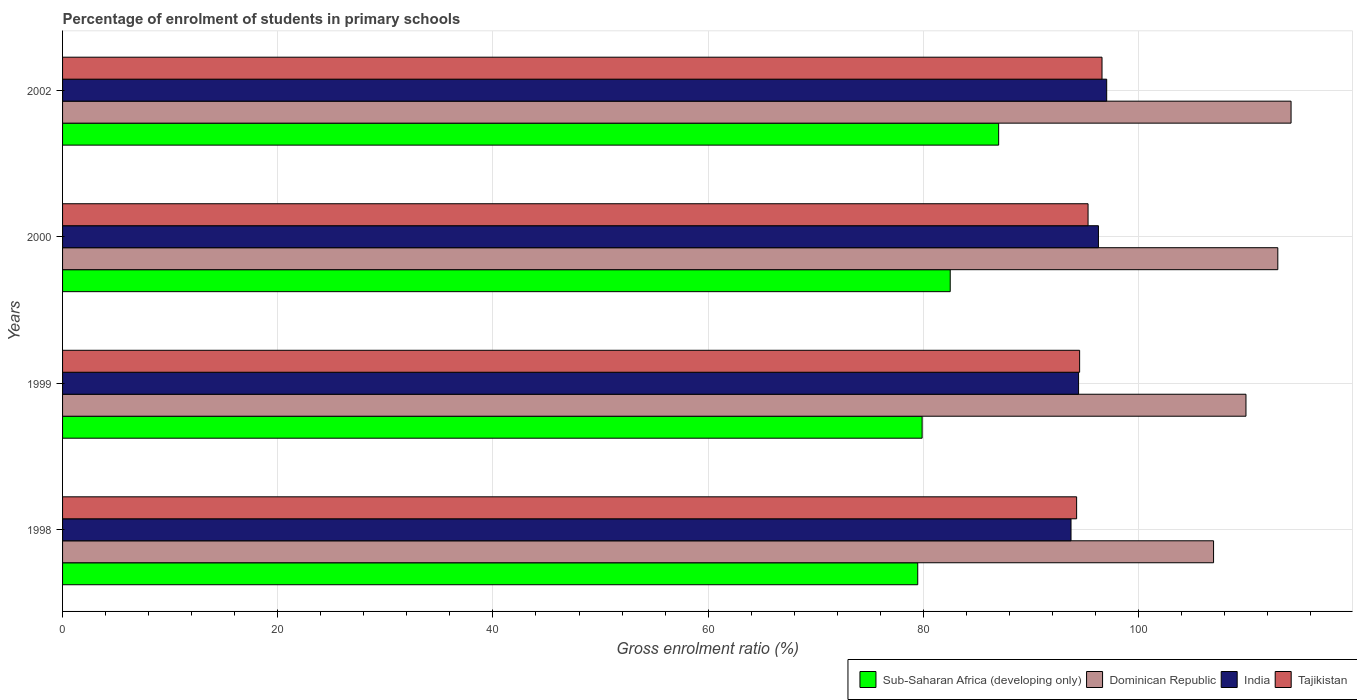How many groups of bars are there?
Give a very brief answer. 4. How many bars are there on the 2nd tick from the bottom?
Your answer should be very brief. 4. What is the label of the 4th group of bars from the top?
Your answer should be very brief. 1998. What is the percentage of students enrolled in primary schools in Dominican Republic in 1999?
Provide a short and direct response. 109.99. Across all years, what is the maximum percentage of students enrolled in primary schools in Sub-Saharan Africa (developing only)?
Provide a succinct answer. 87. Across all years, what is the minimum percentage of students enrolled in primary schools in Tajikistan?
Make the answer very short. 94.25. In which year was the percentage of students enrolled in primary schools in Dominican Republic maximum?
Make the answer very short. 2002. What is the total percentage of students enrolled in primary schools in Dominican Republic in the graph?
Provide a short and direct response. 444.09. What is the difference between the percentage of students enrolled in primary schools in Tajikistan in 1998 and that in 1999?
Your response must be concise. -0.28. What is the difference between the percentage of students enrolled in primary schools in Dominican Republic in 2000 and the percentage of students enrolled in primary schools in India in 2002?
Provide a succinct answer. 15.9. What is the average percentage of students enrolled in primary schools in Dominican Republic per year?
Ensure brevity in your answer.  111.02. In the year 2002, what is the difference between the percentage of students enrolled in primary schools in Dominican Republic and percentage of students enrolled in primary schools in Tajikistan?
Give a very brief answer. 17.57. What is the ratio of the percentage of students enrolled in primary schools in Sub-Saharan Africa (developing only) in 1998 to that in 2000?
Offer a very short reply. 0.96. Is the percentage of students enrolled in primary schools in India in 1999 less than that in 2000?
Provide a short and direct response. Yes. Is the difference between the percentage of students enrolled in primary schools in Dominican Republic in 1998 and 2002 greater than the difference between the percentage of students enrolled in primary schools in Tajikistan in 1998 and 2002?
Your answer should be very brief. No. What is the difference between the highest and the second highest percentage of students enrolled in primary schools in Tajikistan?
Offer a terse response. 1.3. What is the difference between the highest and the lowest percentage of students enrolled in primary schools in Sub-Saharan Africa (developing only)?
Your answer should be very brief. 7.52. In how many years, is the percentage of students enrolled in primary schools in Tajikistan greater than the average percentage of students enrolled in primary schools in Tajikistan taken over all years?
Your response must be concise. 2. What does the 1st bar from the bottom in 1999 represents?
Your response must be concise. Sub-Saharan Africa (developing only). Are all the bars in the graph horizontal?
Provide a short and direct response. Yes. Are the values on the major ticks of X-axis written in scientific E-notation?
Give a very brief answer. No. Does the graph contain grids?
Give a very brief answer. Yes. How many legend labels are there?
Ensure brevity in your answer.  4. What is the title of the graph?
Provide a short and direct response. Percentage of enrolment of students in primary schools. What is the label or title of the X-axis?
Make the answer very short. Gross enrolment ratio (%). What is the label or title of the Y-axis?
Ensure brevity in your answer.  Years. What is the Gross enrolment ratio (%) of Sub-Saharan Africa (developing only) in 1998?
Offer a very short reply. 79.48. What is the Gross enrolment ratio (%) of Dominican Republic in 1998?
Offer a very short reply. 106.98. What is the Gross enrolment ratio (%) in India in 1998?
Ensure brevity in your answer.  93.73. What is the Gross enrolment ratio (%) in Tajikistan in 1998?
Provide a short and direct response. 94.25. What is the Gross enrolment ratio (%) of Sub-Saharan Africa (developing only) in 1999?
Ensure brevity in your answer.  79.89. What is the Gross enrolment ratio (%) of Dominican Republic in 1999?
Your answer should be compact. 109.99. What is the Gross enrolment ratio (%) in India in 1999?
Give a very brief answer. 94.43. What is the Gross enrolment ratio (%) in Tajikistan in 1999?
Make the answer very short. 94.53. What is the Gross enrolment ratio (%) of Sub-Saharan Africa (developing only) in 2000?
Provide a succinct answer. 82.5. What is the Gross enrolment ratio (%) of Dominican Republic in 2000?
Give a very brief answer. 112.95. What is the Gross enrolment ratio (%) of India in 2000?
Ensure brevity in your answer.  96.28. What is the Gross enrolment ratio (%) of Tajikistan in 2000?
Give a very brief answer. 95.31. What is the Gross enrolment ratio (%) in Sub-Saharan Africa (developing only) in 2002?
Make the answer very short. 87. What is the Gross enrolment ratio (%) in Dominican Republic in 2002?
Provide a short and direct response. 114.18. What is the Gross enrolment ratio (%) of India in 2002?
Keep it short and to the point. 97.04. What is the Gross enrolment ratio (%) in Tajikistan in 2002?
Your answer should be compact. 96.61. Across all years, what is the maximum Gross enrolment ratio (%) of Sub-Saharan Africa (developing only)?
Provide a short and direct response. 87. Across all years, what is the maximum Gross enrolment ratio (%) of Dominican Republic?
Provide a short and direct response. 114.18. Across all years, what is the maximum Gross enrolment ratio (%) of India?
Make the answer very short. 97.04. Across all years, what is the maximum Gross enrolment ratio (%) in Tajikistan?
Offer a terse response. 96.61. Across all years, what is the minimum Gross enrolment ratio (%) in Sub-Saharan Africa (developing only)?
Give a very brief answer. 79.48. Across all years, what is the minimum Gross enrolment ratio (%) in Dominican Republic?
Your response must be concise. 106.98. Across all years, what is the minimum Gross enrolment ratio (%) in India?
Provide a succinct answer. 93.73. Across all years, what is the minimum Gross enrolment ratio (%) of Tajikistan?
Ensure brevity in your answer.  94.25. What is the total Gross enrolment ratio (%) in Sub-Saharan Africa (developing only) in the graph?
Offer a very short reply. 328.87. What is the total Gross enrolment ratio (%) of Dominican Republic in the graph?
Offer a very short reply. 444.09. What is the total Gross enrolment ratio (%) in India in the graph?
Your answer should be very brief. 381.48. What is the total Gross enrolment ratio (%) of Tajikistan in the graph?
Offer a very short reply. 380.7. What is the difference between the Gross enrolment ratio (%) of Sub-Saharan Africa (developing only) in 1998 and that in 1999?
Offer a terse response. -0.41. What is the difference between the Gross enrolment ratio (%) in Dominican Republic in 1998 and that in 1999?
Keep it short and to the point. -3.01. What is the difference between the Gross enrolment ratio (%) in India in 1998 and that in 1999?
Ensure brevity in your answer.  -0.7. What is the difference between the Gross enrolment ratio (%) of Tajikistan in 1998 and that in 1999?
Offer a very short reply. -0.28. What is the difference between the Gross enrolment ratio (%) in Sub-Saharan Africa (developing only) in 1998 and that in 2000?
Your answer should be very brief. -3.02. What is the difference between the Gross enrolment ratio (%) in Dominican Republic in 1998 and that in 2000?
Your answer should be compact. -5.97. What is the difference between the Gross enrolment ratio (%) of India in 1998 and that in 2000?
Provide a short and direct response. -2.55. What is the difference between the Gross enrolment ratio (%) in Tajikistan in 1998 and that in 2000?
Your response must be concise. -1.06. What is the difference between the Gross enrolment ratio (%) in Sub-Saharan Africa (developing only) in 1998 and that in 2002?
Provide a short and direct response. -7.52. What is the difference between the Gross enrolment ratio (%) of Dominican Republic in 1998 and that in 2002?
Offer a very short reply. -7.2. What is the difference between the Gross enrolment ratio (%) of India in 1998 and that in 2002?
Your answer should be compact. -3.32. What is the difference between the Gross enrolment ratio (%) in Tajikistan in 1998 and that in 2002?
Ensure brevity in your answer.  -2.36. What is the difference between the Gross enrolment ratio (%) of Sub-Saharan Africa (developing only) in 1999 and that in 2000?
Make the answer very short. -2.61. What is the difference between the Gross enrolment ratio (%) in Dominican Republic in 1999 and that in 2000?
Your answer should be compact. -2.96. What is the difference between the Gross enrolment ratio (%) in India in 1999 and that in 2000?
Your response must be concise. -1.85. What is the difference between the Gross enrolment ratio (%) in Tajikistan in 1999 and that in 2000?
Make the answer very short. -0.78. What is the difference between the Gross enrolment ratio (%) of Sub-Saharan Africa (developing only) in 1999 and that in 2002?
Your response must be concise. -7.11. What is the difference between the Gross enrolment ratio (%) in Dominican Republic in 1999 and that in 2002?
Ensure brevity in your answer.  -4.19. What is the difference between the Gross enrolment ratio (%) of India in 1999 and that in 2002?
Your response must be concise. -2.61. What is the difference between the Gross enrolment ratio (%) of Tajikistan in 1999 and that in 2002?
Your answer should be very brief. -2.08. What is the difference between the Gross enrolment ratio (%) in Sub-Saharan Africa (developing only) in 2000 and that in 2002?
Provide a short and direct response. -4.5. What is the difference between the Gross enrolment ratio (%) of Dominican Republic in 2000 and that in 2002?
Your answer should be very brief. -1.23. What is the difference between the Gross enrolment ratio (%) of India in 2000 and that in 2002?
Make the answer very short. -0.77. What is the difference between the Gross enrolment ratio (%) in Tajikistan in 2000 and that in 2002?
Offer a terse response. -1.3. What is the difference between the Gross enrolment ratio (%) in Sub-Saharan Africa (developing only) in 1998 and the Gross enrolment ratio (%) in Dominican Republic in 1999?
Your answer should be compact. -30.51. What is the difference between the Gross enrolment ratio (%) of Sub-Saharan Africa (developing only) in 1998 and the Gross enrolment ratio (%) of India in 1999?
Provide a succinct answer. -14.95. What is the difference between the Gross enrolment ratio (%) of Sub-Saharan Africa (developing only) in 1998 and the Gross enrolment ratio (%) of Tajikistan in 1999?
Your answer should be compact. -15.05. What is the difference between the Gross enrolment ratio (%) of Dominican Republic in 1998 and the Gross enrolment ratio (%) of India in 1999?
Give a very brief answer. 12.55. What is the difference between the Gross enrolment ratio (%) of Dominican Republic in 1998 and the Gross enrolment ratio (%) of Tajikistan in 1999?
Keep it short and to the point. 12.45. What is the difference between the Gross enrolment ratio (%) in India in 1998 and the Gross enrolment ratio (%) in Tajikistan in 1999?
Offer a terse response. -0.8. What is the difference between the Gross enrolment ratio (%) in Sub-Saharan Africa (developing only) in 1998 and the Gross enrolment ratio (%) in Dominican Republic in 2000?
Provide a succinct answer. -33.47. What is the difference between the Gross enrolment ratio (%) of Sub-Saharan Africa (developing only) in 1998 and the Gross enrolment ratio (%) of India in 2000?
Give a very brief answer. -16.79. What is the difference between the Gross enrolment ratio (%) of Sub-Saharan Africa (developing only) in 1998 and the Gross enrolment ratio (%) of Tajikistan in 2000?
Offer a very short reply. -15.83. What is the difference between the Gross enrolment ratio (%) of Dominican Republic in 1998 and the Gross enrolment ratio (%) of India in 2000?
Offer a terse response. 10.7. What is the difference between the Gross enrolment ratio (%) in Dominican Republic in 1998 and the Gross enrolment ratio (%) in Tajikistan in 2000?
Your answer should be compact. 11.67. What is the difference between the Gross enrolment ratio (%) in India in 1998 and the Gross enrolment ratio (%) in Tajikistan in 2000?
Your answer should be very brief. -1.58. What is the difference between the Gross enrolment ratio (%) of Sub-Saharan Africa (developing only) in 1998 and the Gross enrolment ratio (%) of Dominican Republic in 2002?
Provide a short and direct response. -34.7. What is the difference between the Gross enrolment ratio (%) in Sub-Saharan Africa (developing only) in 1998 and the Gross enrolment ratio (%) in India in 2002?
Provide a short and direct response. -17.56. What is the difference between the Gross enrolment ratio (%) in Sub-Saharan Africa (developing only) in 1998 and the Gross enrolment ratio (%) in Tajikistan in 2002?
Give a very brief answer. -17.13. What is the difference between the Gross enrolment ratio (%) of Dominican Republic in 1998 and the Gross enrolment ratio (%) of India in 2002?
Offer a very short reply. 9.93. What is the difference between the Gross enrolment ratio (%) of Dominican Republic in 1998 and the Gross enrolment ratio (%) of Tajikistan in 2002?
Provide a short and direct response. 10.37. What is the difference between the Gross enrolment ratio (%) in India in 1998 and the Gross enrolment ratio (%) in Tajikistan in 2002?
Your answer should be very brief. -2.88. What is the difference between the Gross enrolment ratio (%) in Sub-Saharan Africa (developing only) in 1999 and the Gross enrolment ratio (%) in Dominican Republic in 2000?
Make the answer very short. -33.06. What is the difference between the Gross enrolment ratio (%) of Sub-Saharan Africa (developing only) in 1999 and the Gross enrolment ratio (%) of India in 2000?
Provide a short and direct response. -16.39. What is the difference between the Gross enrolment ratio (%) in Sub-Saharan Africa (developing only) in 1999 and the Gross enrolment ratio (%) in Tajikistan in 2000?
Provide a succinct answer. -15.42. What is the difference between the Gross enrolment ratio (%) in Dominican Republic in 1999 and the Gross enrolment ratio (%) in India in 2000?
Your answer should be compact. 13.71. What is the difference between the Gross enrolment ratio (%) of Dominican Republic in 1999 and the Gross enrolment ratio (%) of Tajikistan in 2000?
Provide a succinct answer. 14.68. What is the difference between the Gross enrolment ratio (%) in India in 1999 and the Gross enrolment ratio (%) in Tajikistan in 2000?
Make the answer very short. -0.88. What is the difference between the Gross enrolment ratio (%) of Sub-Saharan Africa (developing only) in 1999 and the Gross enrolment ratio (%) of Dominican Republic in 2002?
Give a very brief answer. -34.29. What is the difference between the Gross enrolment ratio (%) of Sub-Saharan Africa (developing only) in 1999 and the Gross enrolment ratio (%) of India in 2002?
Your answer should be very brief. -17.15. What is the difference between the Gross enrolment ratio (%) in Sub-Saharan Africa (developing only) in 1999 and the Gross enrolment ratio (%) in Tajikistan in 2002?
Provide a succinct answer. -16.72. What is the difference between the Gross enrolment ratio (%) in Dominican Republic in 1999 and the Gross enrolment ratio (%) in India in 2002?
Make the answer very short. 12.95. What is the difference between the Gross enrolment ratio (%) of Dominican Republic in 1999 and the Gross enrolment ratio (%) of Tajikistan in 2002?
Give a very brief answer. 13.38. What is the difference between the Gross enrolment ratio (%) of India in 1999 and the Gross enrolment ratio (%) of Tajikistan in 2002?
Offer a terse response. -2.18. What is the difference between the Gross enrolment ratio (%) in Sub-Saharan Africa (developing only) in 2000 and the Gross enrolment ratio (%) in Dominican Republic in 2002?
Provide a succinct answer. -31.68. What is the difference between the Gross enrolment ratio (%) in Sub-Saharan Africa (developing only) in 2000 and the Gross enrolment ratio (%) in India in 2002?
Keep it short and to the point. -14.54. What is the difference between the Gross enrolment ratio (%) of Sub-Saharan Africa (developing only) in 2000 and the Gross enrolment ratio (%) of Tajikistan in 2002?
Provide a short and direct response. -14.11. What is the difference between the Gross enrolment ratio (%) in Dominican Republic in 2000 and the Gross enrolment ratio (%) in India in 2002?
Offer a terse response. 15.9. What is the difference between the Gross enrolment ratio (%) in Dominican Republic in 2000 and the Gross enrolment ratio (%) in Tajikistan in 2002?
Make the answer very short. 16.34. What is the difference between the Gross enrolment ratio (%) of India in 2000 and the Gross enrolment ratio (%) of Tajikistan in 2002?
Your answer should be compact. -0.33. What is the average Gross enrolment ratio (%) in Sub-Saharan Africa (developing only) per year?
Provide a short and direct response. 82.22. What is the average Gross enrolment ratio (%) in Dominican Republic per year?
Give a very brief answer. 111.02. What is the average Gross enrolment ratio (%) in India per year?
Your answer should be compact. 95.37. What is the average Gross enrolment ratio (%) in Tajikistan per year?
Your answer should be compact. 95.17. In the year 1998, what is the difference between the Gross enrolment ratio (%) in Sub-Saharan Africa (developing only) and Gross enrolment ratio (%) in Dominican Republic?
Your answer should be compact. -27.49. In the year 1998, what is the difference between the Gross enrolment ratio (%) in Sub-Saharan Africa (developing only) and Gross enrolment ratio (%) in India?
Offer a very short reply. -14.25. In the year 1998, what is the difference between the Gross enrolment ratio (%) of Sub-Saharan Africa (developing only) and Gross enrolment ratio (%) of Tajikistan?
Your response must be concise. -14.77. In the year 1998, what is the difference between the Gross enrolment ratio (%) of Dominican Republic and Gross enrolment ratio (%) of India?
Provide a short and direct response. 13.25. In the year 1998, what is the difference between the Gross enrolment ratio (%) in Dominican Republic and Gross enrolment ratio (%) in Tajikistan?
Make the answer very short. 12.73. In the year 1998, what is the difference between the Gross enrolment ratio (%) of India and Gross enrolment ratio (%) of Tajikistan?
Your answer should be compact. -0.52. In the year 1999, what is the difference between the Gross enrolment ratio (%) in Sub-Saharan Africa (developing only) and Gross enrolment ratio (%) in Dominican Republic?
Offer a terse response. -30.1. In the year 1999, what is the difference between the Gross enrolment ratio (%) of Sub-Saharan Africa (developing only) and Gross enrolment ratio (%) of India?
Provide a short and direct response. -14.54. In the year 1999, what is the difference between the Gross enrolment ratio (%) of Sub-Saharan Africa (developing only) and Gross enrolment ratio (%) of Tajikistan?
Keep it short and to the point. -14.64. In the year 1999, what is the difference between the Gross enrolment ratio (%) in Dominican Republic and Gross enrolment ratio (%) in India?
Your answer should be compact. 15.56. In the year 1999, what is the difference between the Gross enrolment ratio (%) in Dominican Republic and Gross enrolment ratio (%) in Tajikistan?
Your response must be concise. 15.46. In the year 1999, what is the difference between the Gross enrolment ratio (%) in India and Gross enrolment ratio (%) in Tajikistan?
Your answer should be very brief. -0.1. In the year 2000, what is the difference between the Gross enrolment ratio (%) of Sub-Saharan Africa (developing only) and Gross enrolment ratio (%) of Dominican Republic?
Provide a succinct answer. -30.45. In the year 2000, what is the difference between the Gross enrolment ratio (%) of Sub-Saharan Africa (developing only) and Gross enrolment ratio (%) of India?
Make the answer very short. -13.78. In the year 2000, what is the difference between the Gross enrolment ratio (%) in Sub-Saharan Africa (developing only) and Gross enrolment ratio (%) in Tajikistan?
Ensure brevity in your answer.  -12.81. In the year 2000, what is the difference between the Gross enrolment ratio (%) of Dominican Republic and Gross enrolment ratio (%) of India?
Ensure brevity in your answer.  16.67. In the year 2000, what is the difference between the Gross enrolment ratio (%) in Dominican Republic and Gross enrolment ratio (%) in Tajikistan?
Offer a very short reply. 17.64. In the year 2000, what is the difference between the Gross enrolment ratio (%) of India and Gross enrolment ratio (%) of Tajikistan?
Offer a very short reply. 0.96. In the year 2002, what is the difference between the Gross enrolment ratio (%) in Sub-Saharan Africa (developing only) and Gross enrolment ratio (%) in Dominican Republic?
Provide a succinct answer. -27.18. In the year 2002, what is the difference between the Gross enrolment ratio (%) of Sub-Saharan Africa (developing only) and Gross enrolment ratio (%) of India?
Ensure brevity in your answer.  -10.04. In the year 2002, what is the difference between the Gross enrolment ratio (%) in Sub-Saharan Africa (developing only) and Gross enrolment ratio (%) in Tajikistan?
Provide a short and direct response. -9.61. In the year 2002, what is the difference between the Gross enrolment ratio (%) of Dominican Republic and Gross enrolment ratio (%) of India?
Give a very brief answer. 17.14. In the year 2002, what is the difference between the Gross enrolment ratio (%) in Dominican Republic and Gross enrolment ratio (%) in Tajikistan?
Give a very brief answer. 17.57. In the year 2002, what is the difference between the Gross enrolment ratio (%) of India and Gross enrolment ratio (%) of Tajikistan?
Provide a succinct answer. 0.43. What is the ratio of the Gross enrolment ratio (%) of Sub-Saharan Africa (developing only) in 1998 to that in 1999?
Ensure brevity in your answer.  0.99. What is the ratio of the Gross enrolment ratio (%) of Dominican Republic in 1998 to that in 1999?
Offer a terse response. 0.97. What is the ratio of the Gross enrolment ratio (%) in India in 1998 to that in 1999?
Your answer should be very brief. 0.99. What is the ratio of the Gross enrolment ratio (%) in Sub-Saharan Africa (developing only) in 1998 to that in 2000?
Offer a terse response. 0.96. What is the ratio of the Gross enrolment ratio (%) of Dominican Republic in 1998 to that in 2000?
Offer a terse response. 0.95. What is the ratio of the Gross enrolment ratio (%) in India in 1998 to that in 2000?
Ensure brevity in your answer.  0.97. What is the ratio of the Gross enrolment ratio (%) in Tajikistan in 1998 to that in 2000?
Make the answer very short. 0.99. What is the ratio of the Gross enrolment ratio (%) of Sub-Saharan Africa (developing only) in 1998 to that in 2002?
Offer a very short reply. 0.91. What is the ratio of the Gross enrolment ratio (%) in Dominican Republic in 1998 to that in 2002?
Ensure brevity in your answer.  0.94. What is the ratio of the Gross enrolment ratio (%) of India in 1998 to that in 2002?
Give a very brief answer. 0.97. What is the ratio of the Gross enrolment ratio (%) of Tajikistan in 1998 to that in 2002?
Your response must be concise. 0.98. What is the ratio of the Gross enrolment ratio (%) in Sub-Saharan Africa (developing only) in 1999 to that in 2000?
Offer a terse response. 0.97. What is the ratio of the Gross enrolment ratio (%) in Dominican Republic in 1999 to that in 2000?
Give a very brief answer. 0.97. What is the ratio of the Gross enrolment ratio (%) of India in 1999 to that in 2000?
Keep it short and to the point. 0.98. What is the ratio of the Gross enrolment ratio (%) in Sub-Saharan Africa (developing only) in 1999 to that in 2002?
Your answer should be very brief. 0.92. What is the ratio of the Gross enrolment ratio (%) of Dominican Republic in 1999 to that in 2002?
Provide a short and direct response. 0.96. What is the ratio of the Gross enrolment ratio (%) in India in 1999 to that in 2002?
Your answer should be compact. 0.97. What is the ratio of the Gross enrolment ratio (%) of Tajikistan in 1999 to that in 2002?
Your answer should be very brief. 0.98. What is the ratio of the Gross enrolment ratio (%) in Sub-Saharan Africa (developing only) in 2000 to that in 2002?
Offer a terse response. 0.95. What is the ratio of the Gross enrolment ratio (%) in India in 2000 to that in 2002?
Provide a short and direct response. 0.99. What is the ratio of the Gross enrolment ratio (%) in Tajikistan in 2000 to that in 2002?
Offer a very short reply. 0.99. What is the difference between the highest and the second highest Gross enrolment ratio (%) in Sub-Saharan Africa (developing only)?
Ensure brevity in your answer.  4.5. What is the difference between the highest and the second highest Gross enrolment ratio (%) in Dominican Republic?
Provide a short and direct response. 1.23. What is the difference between the highest and the second highest Gross enrolment ratio (%) of India?
Your answer should be very brief. 0.77. What is the difference between the highest and the second highest Gross enrolment ratio (%) of Tajikistan?
Give a very brief answer. 1.3. What is the difference between the highest and the lowest Gross enrolment ratio (%) in Sub-Saharan Africa (developing only)?
Provide a short and direct response. 7.52. What is the difference between the highest and the lowest Gross enrolment ratio (%) of Dominican Republic?
Ensure brevity in your answer.  7.2. What is the difference between the highest and the lowest Gross enrolment ratio (%) of India?
Give a very brief answer. 3.32. What is the difference between the highest and the lowest Gross enrolment ratio (%) of Tajikistan?
Provide a short and direct response. 2.36. 